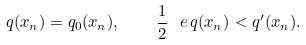Convert formula to latex. <formula><loc_0><loc_0><loc_500><loc_500>q ( x _ { n } ) = q _ { 0 } ( x _ { n } ) , \quad \frac { 1 } { 2 } \, \ e \, q ( x _ { n } ) < q ^ { \prime } ( x _ { n } ) .</formula> 